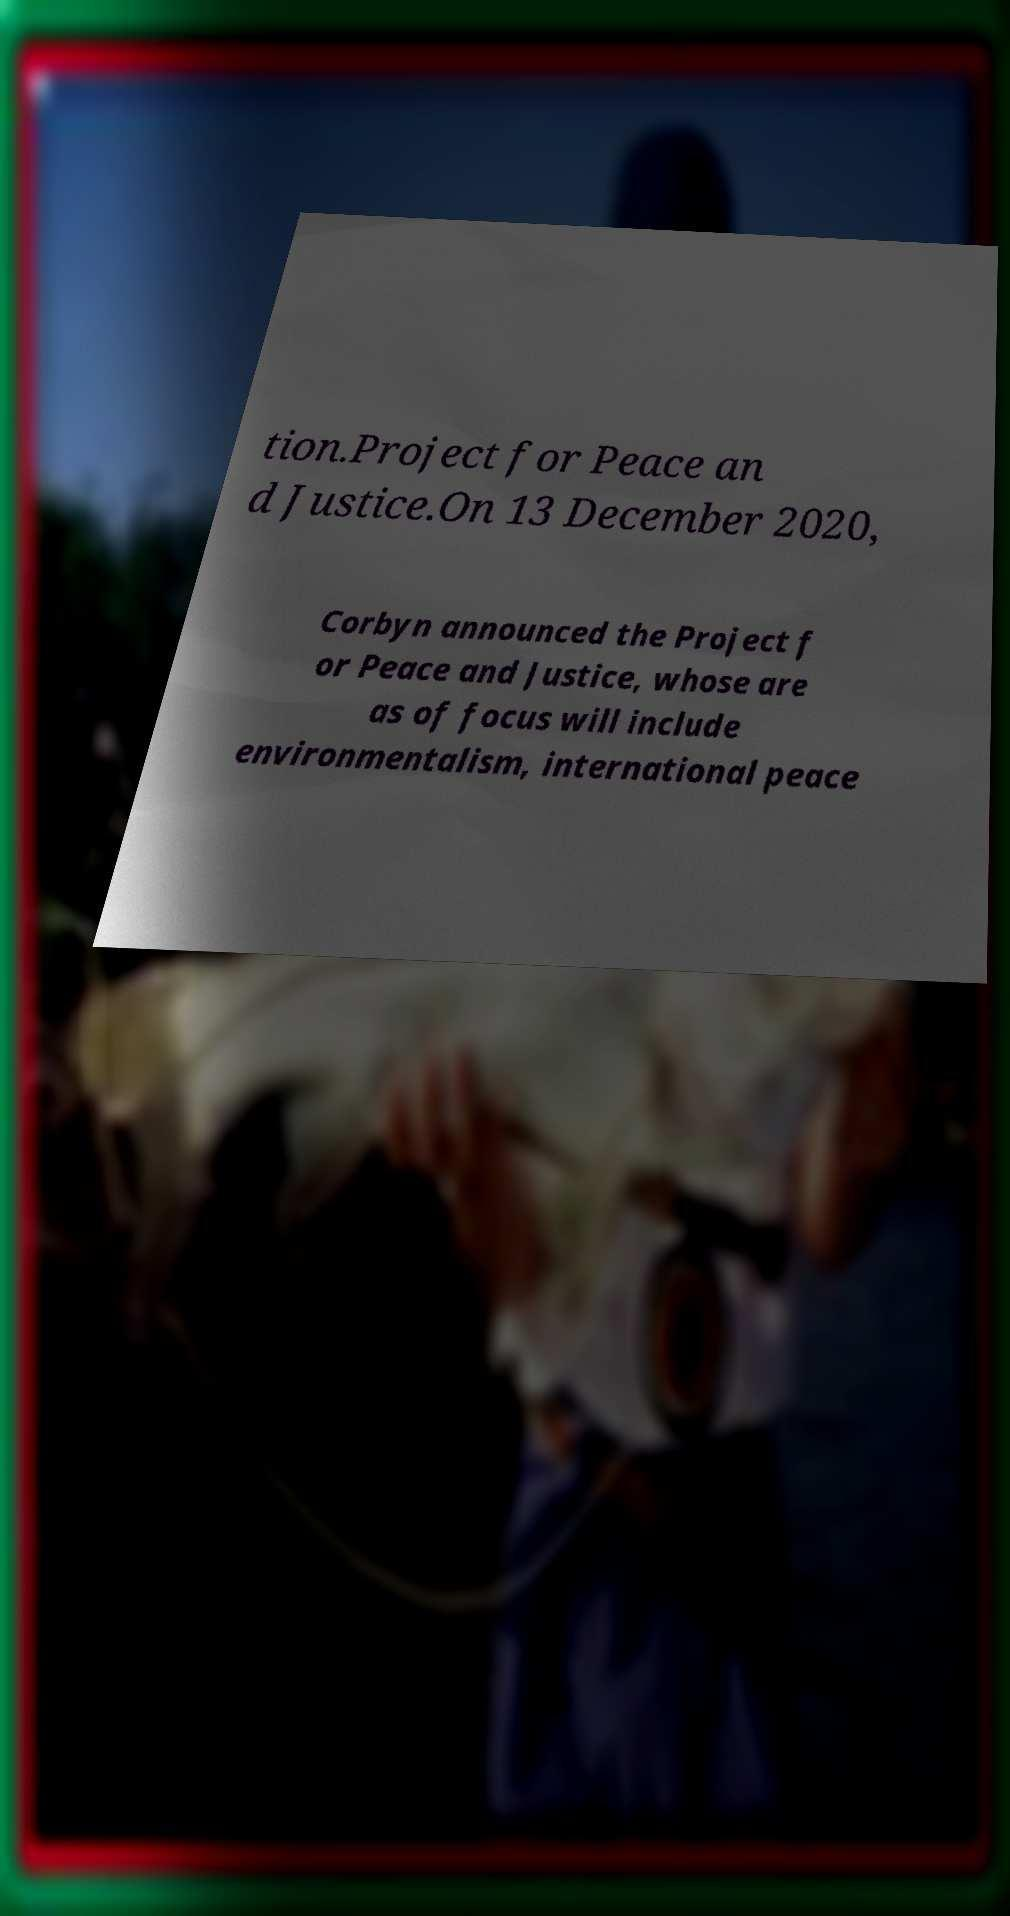There's text embedded in this image that I need extracted. Can you transcribe it verbatim? tion.Project for Peace an d Justice.On 13 December 2020, Corbyn announced the Project f or Peace and Justice, whose are as of focus will include environmentalism, international peace 